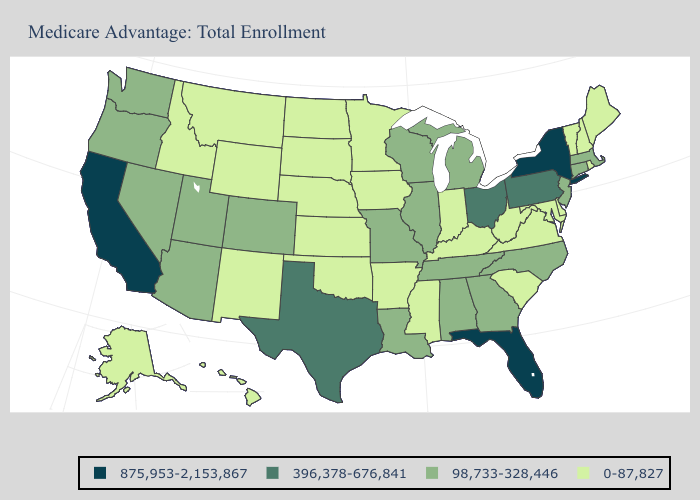What is the highest value in the USA?
Quick response, please. 875,953-2,153,867. Name the states that have a value in the range 98,733-328,446?
Write a very short answer. Alabama, Arizona, Colorado, Connecticut, Georgia, Illinois, Louisiana, Massachusetts, Michigan, Missouri, North Carolina, New Jersey, Nevada, Oregon, Tennessee, Utah, Washington, Wisconsin. What is the highest value in the USA?
Answer briefly. 875,953-2,153,867. What is the value of Minnesota?
Concise answer only. 0-87,827. Name the states that have a value in the range 0-87,827?
Concise answer only. Alaska, Arkansas, Delaware, Hawaii, Iowa, Idaho, Indiana, Kansas, Kentucky, Maryland, Maine, Minnesota, Mississippi, Montana, North Dakota, Nebraska, New Hampshire, New Mexico, Oklahoma, Rhode Island, South Carolina, South Dakota, Virginia, Vermont, West Virginia, Wyoming. Does Idaho have the lowest value in the USA?
Concise answer only. Yes. Does California have the highest value in the USA?
Write a very short answer. Yes. What is the highest value in states that border Georgia?
Answer briefly. 875,953-2,153,867. Does Washington have the highest value in the West?
Concise answer only. No. Is the legend a continuous bar?
Be succinct. No. Which states have the highest value in the USA?
Keep it brief. California, Florida, New York. What is the value of Idaho?
Write a very short answer. 0-87,827. Does Nevada have a higher value than Pennsylvania?
Give a very brief answer. No. What is the highest value in states that border Delaware?
Concise answer only. 396,378-676,841. Does Iowa have the lowest value in the USA?
Short answer required. Yes. 